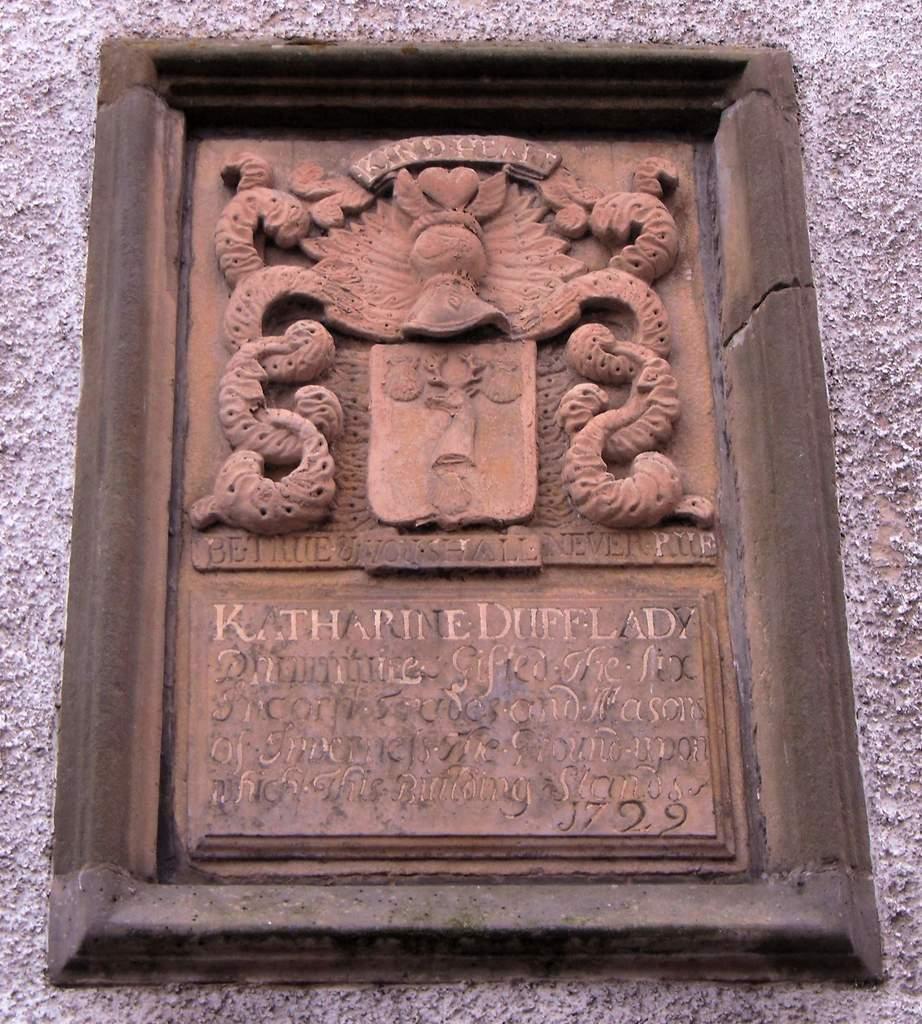In one or two sentences, can you explain what this image depicts? In the center of this picture there is a wooden picture frame on which we can see the text is printed and we can see the sculptures of some objects. In the background there is an object seems to be the wall. 